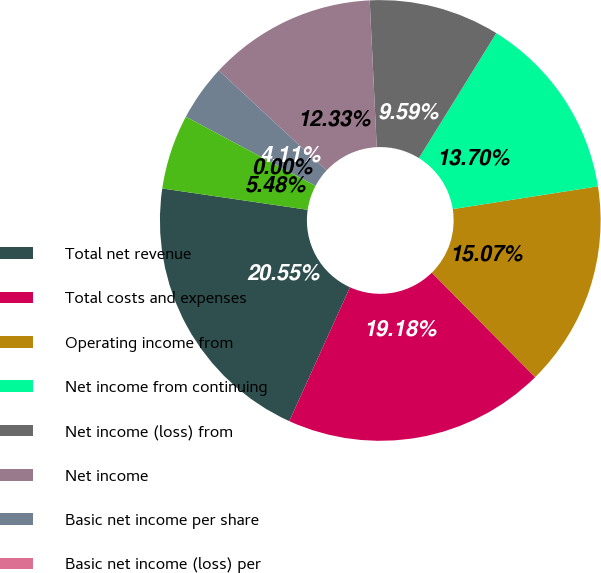<chart> <loc_0><loc_0><loc_500><loc_500><pie_chart><fcel>Total net revenue<fcel>Total costs and expenses<fcel>Operating income from<fcel>Net income from continuing<fcel>Net income (loss) from<fcel>Net income<fcel>Basic net income per share<fcel>Basic net income (loss) per<fcel>Diluted net income per share<nl><fcel>20.55%<fcel>19.18%<fcel>15.07%<fcel>13.7%<fcel>9.59%<fcel>12.33%<fcel>4.11%<fcel>0.0%<fcel>5.48%<nl></chart> 